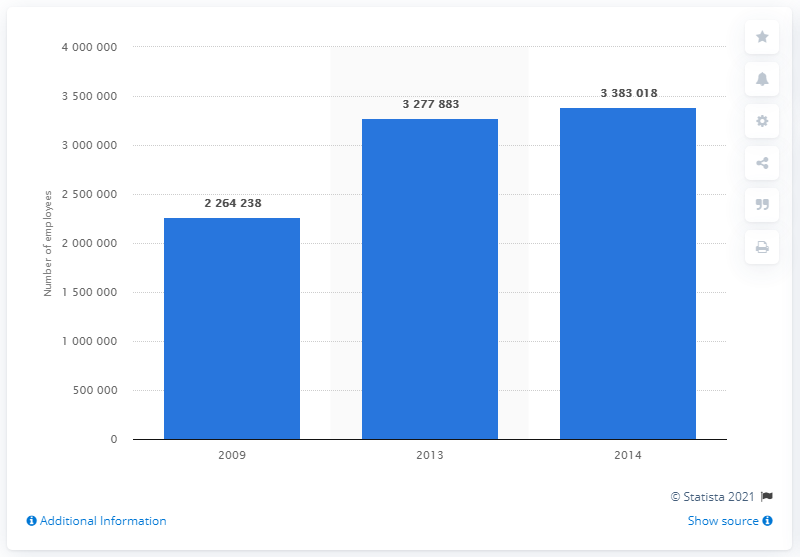Highlight a few significant elements in this photo. In 2014, the manufacturing industry in Turkey employed approximately 338,3018 people. 